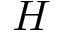Convert formula to latex. <formula><loc_0><loc_0><loc_500><loc_500>H</formula> 